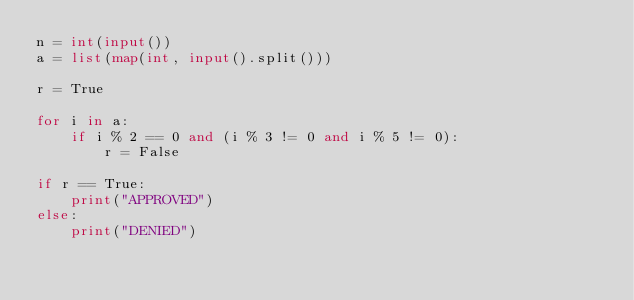<code> <loc_0><loc_0><loc_500><loc_500><_Python_>n = int(input())
a = list(map(int, input().split()))

r = True

for i in a:
    if i % 2 == 0 and (i % 3 != 0 and i % 5 != 0):
        r = False

if r == True:
    print("APPROVED")
else:
    print("DENIED")</code> 